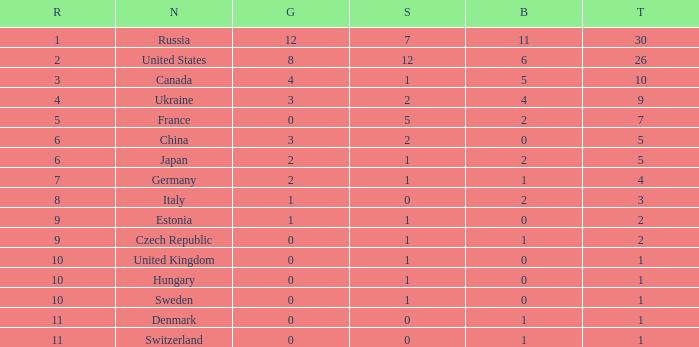Which silver has a Gold smaller than 12, a Rank smaller than 5, and a Bronze of 5? 1.0. 